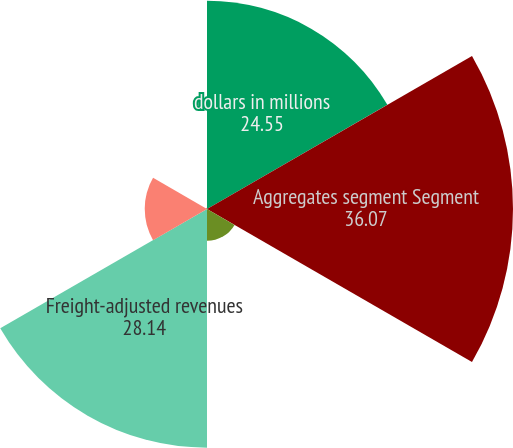<chart> <loc_0><loc_0><loc_500><loc_500><pie_chart><fcel>dollars in millions<fcel>Aggregates segment Segment<fcel>Freight & delivery revenues ^1<fcel>Freight-adjusted revenues<fcel>Unit shipments - tons<fcel>Freight-adjusted sales price<nl><fcel>24.55%<fcel>36.07%<fcel>3.75%<fcel>28.14%<fcel>7.34%<fcel>0.15%<nl></chart> 